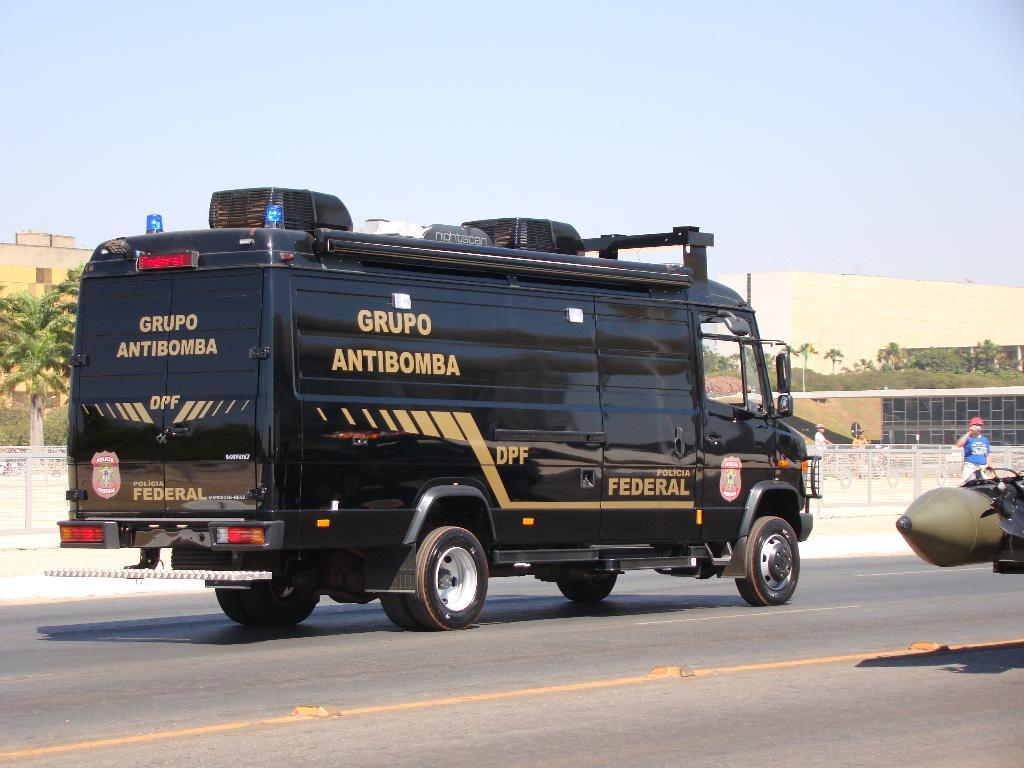<image>
Create a compact narrative representing the image presented. A large black Federal van says Grupo Antibomba. 